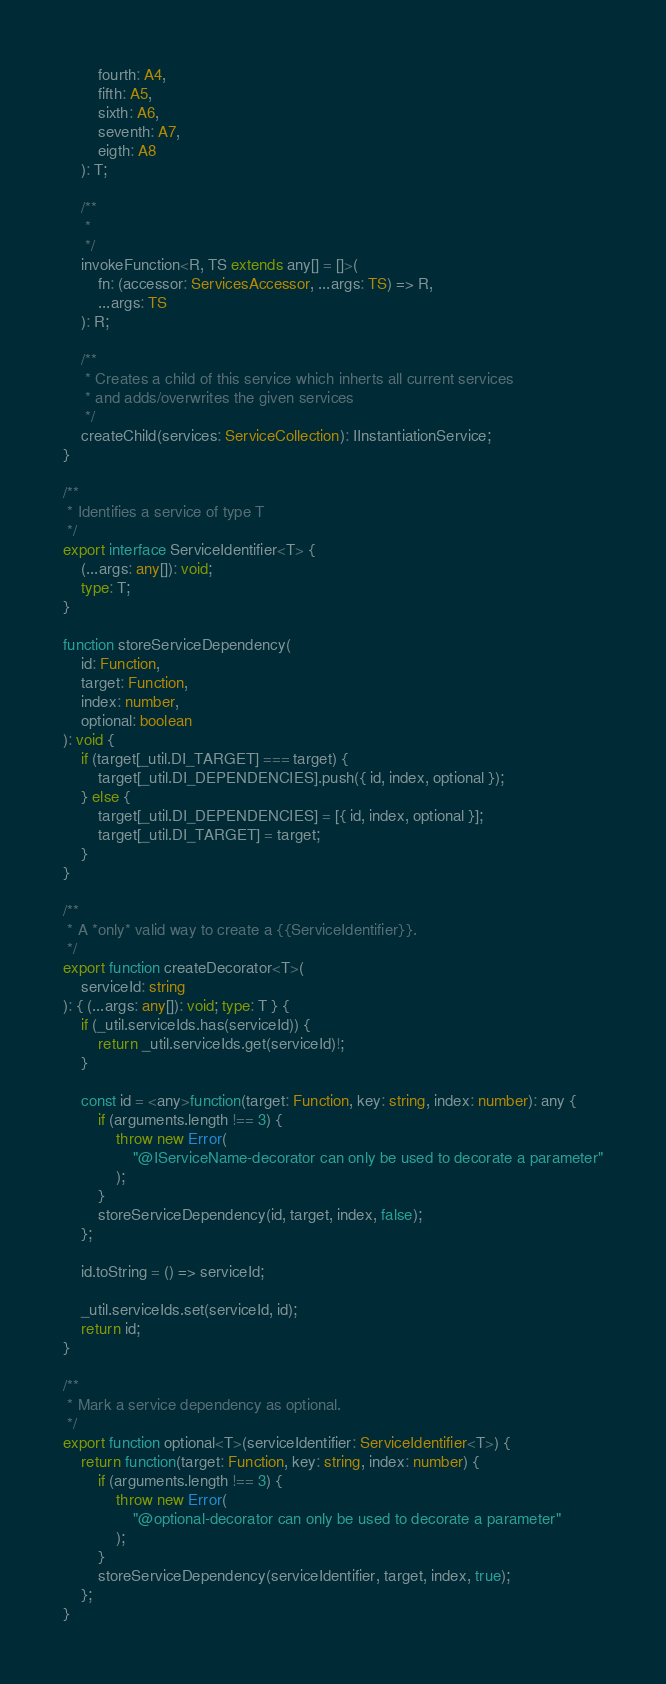Convert code to text. <code><loc_0><loc_0><loc_500><loc_500><_TypeScript_>		fourth: A4,
		fifth: A5,
		sixth: A6,
		seventh: A7,
		eigth: A8
	): T;

	/**
	 *
	 */
	invokeFunction<R, TS extends any[] = []>(
		fn: (accessor: ServicesAccessor, ...args: TS) => R,
		...args: TS
	): R;

	/**
	 * Creates a child of this service which inherts all current services
	 * and adds/overwrites the given services
	 */
	createChild(services: ServiceCollection): IInstantiationService;
}

/**
 * Identifies a service of type T
 */
export interface ServiceIdentifier<T> {
	(...args: any[]): void;
	type: T;
}

function storeServiceDependency(
	id: Function,
	target: Function,
	index: number,
	optional: boolean
): void {
	if (target[_util.DI_TARGET] === target) {
		target[_util.DI_DEPENDENCIES].push({ id, index, optional });
	} else {
		target[_util.DI_DEPENDENCIES] = [{ id, index, optional }];
		target[_util.DI_TARGET] = target;
	}
}

/**
 * A *only* valid way to create a {{ServiceIdentifier}}.
 */
export function createDecorator<T>(
	serviceId: string
): { (...args: any[]): void; type: T } {
	if (_util.serviceIds.has(serviceId)) {
		return _util.serviceIds.get(serviceId)!;
	}

	const id = <any>function(target: Function, key: string, index: number): any {
		if (arguments.length !== 3) {
			throw new Error(
				"@IServiceName-decorator can only be used to decorate a parameter"
			);
		}
		storeServiceDependency(id, target, index, false);
	};

	id.toString = () => serviceId;

	_util.serviceIds.set(serviceId, id);
	return id;
}

/**
 * Mark a service dependency as optional.
 */
export function optional<T>(serviceIdentifier: ServiceIdentifier<T>) {
	return function(target: Function, key: string, index: number) {
		if (arguments.length !== 3) {
			throw new Error(
				"@optional-decorator can only be used to decorate a parameter"
			);
		}
		storeServiceDependency(serviceIdentifier, target, index, true);
	};
}
</code> 